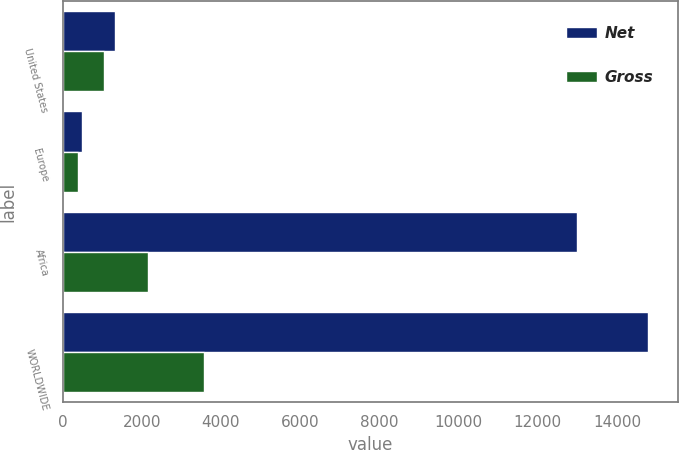Convert chart. <chart><loc_0><loc_0><loc_500><loc_500><stacked_bar_chart><ecel><fcel>United States<fcel>Europe<fcel>Africa<fcel>WORLDWIDE<nl><fcel>Net<fcel>1318<fcel>493<fcel>12978<fcel>14789<nl><fcel>Gross<fcel>1035<fcel>393<fcel>2151<fcel>3579<nl></chart> 